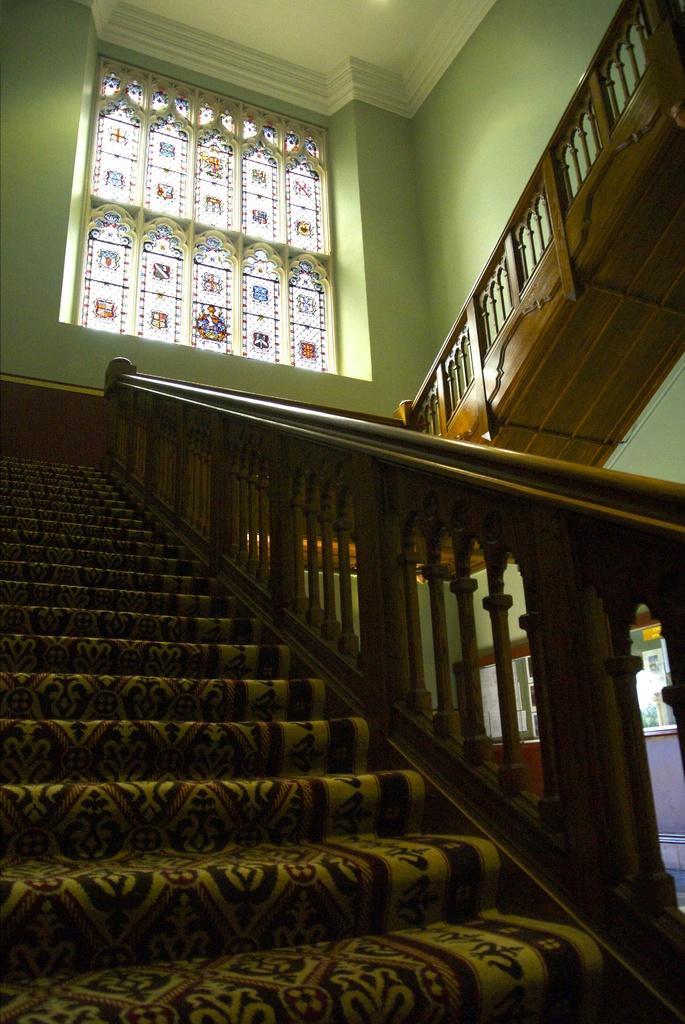Can you describe this image briefly? In this image we can see the stairs and handrails. At the top we can see a wall and a roof. On the wall we can see a window with glass. On the right side, we can see a wall behind the handrail. 